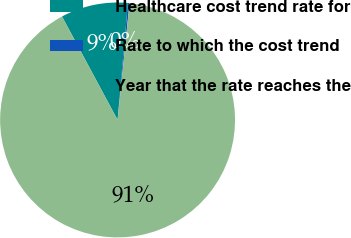Convert chart to OTSL. <chart><loc_0><loc_0><loc_500><loc_500><pie_chart><fcel>Healthcare cost trend rate for<fcel>Rate to which the cost trend<fcel>Year that the rate reaches the<nl><fcel>9.25%<fcel>0.22%<fcel>90.52%<nl></chart> 